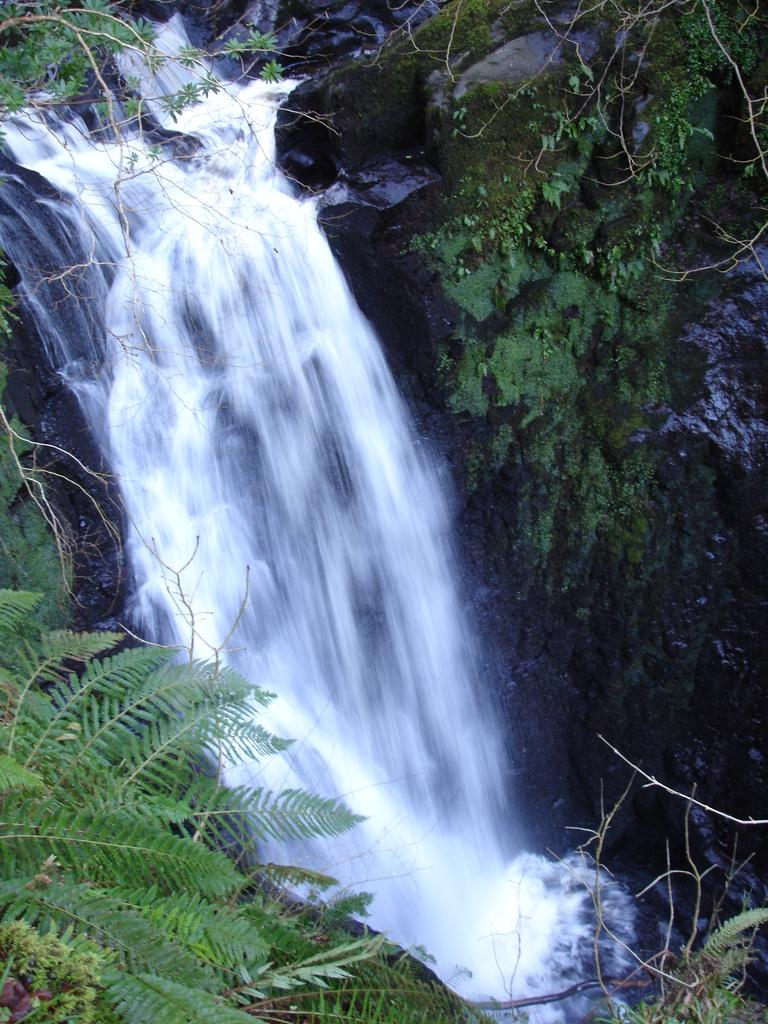What type of vegetation can be seen in the image? There are trees in the image. What part of the trees can be seen in the image? There are leaves in the image. What type of natural formation can be seen in the image? There are rocks in the image. What type of water feature can be seen in the image? There is a waterfall in the image. What type of bottle can be seen in the image? There is no bottle present in the image. Can you describe the taste of the water in the waterfall? The taste of the water in the waterfall cannot be determined from the image, as taste is not a visual characteristic. 